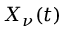<formula> <loc_0><loc_0><loc_500><loc_500>X _ { \nu } ( t )</formula> 